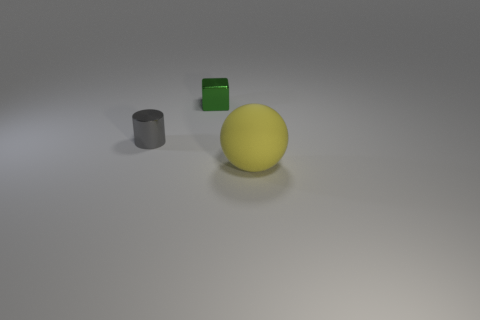How many cylinders are tiny gray metal objects or green shiny things?
Make the answer very short. 1. Is there any other thing that has the same size as the green thing?
Offer a terse response. Yes. There is a yellow thing right of the metallic cylinder; is its shape the same as the tiny green thing?
Provide a short and direct response. No. The metal cube has what color?
Provide a succinct answer. Green. What number of objects are either large green matte objects or objects behind the large matte thing?
Keep it short and to the point. 2. What is the size of the thing that is behind the big ball and right of the gray cylinder?
Your answer should be compact. Small. There is a green block; are there any metallic cylinders to the right of it?
Ensure brevity in your answer.  No. There is a metal object that is in front of the tiny metal cube; are there any large things that are behind it?
Provide a succinct answer. No. Is the number of small gray objects to the right of the gray cylinder the same as the number of large matte balls behind the yellow ball?
Your answer should be very brief. Yes. There is another thing that is the same material as the gray thing; what color is it?
Your answer should be very brief. Green. 